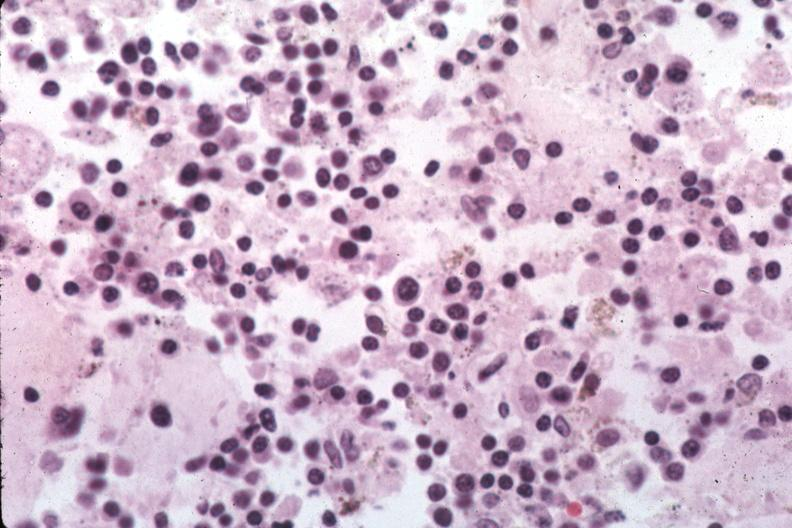does this image show organisms are easily evident?
Answer the question using a single word or phrase. Yes 